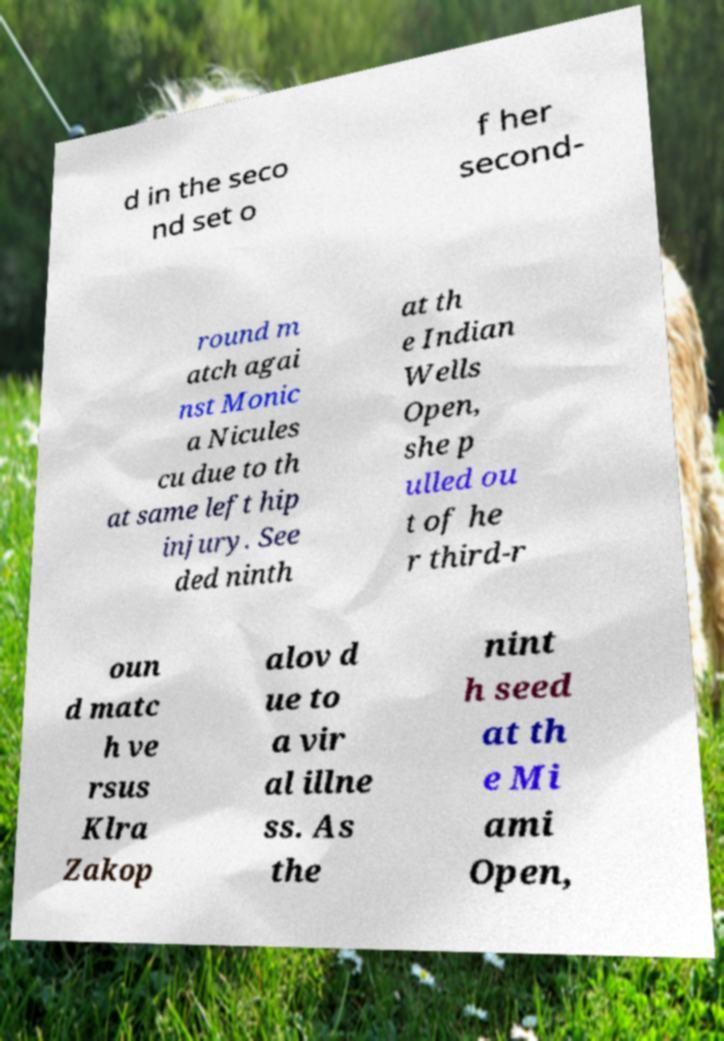Can you accurately transcribe the text from the provided image for me? d in the seco nd set o f her second- round m atch agai nst Monic a Nicules cu due to th at same left hip injury. See ded ninth at th e Indian Wells Open, she p ulled ou t of he r third-r oun d matc h ve rsus Klra Zakop alov d ue to a vir al illne ss. As the nint h seed at th e Mi ami Open, 